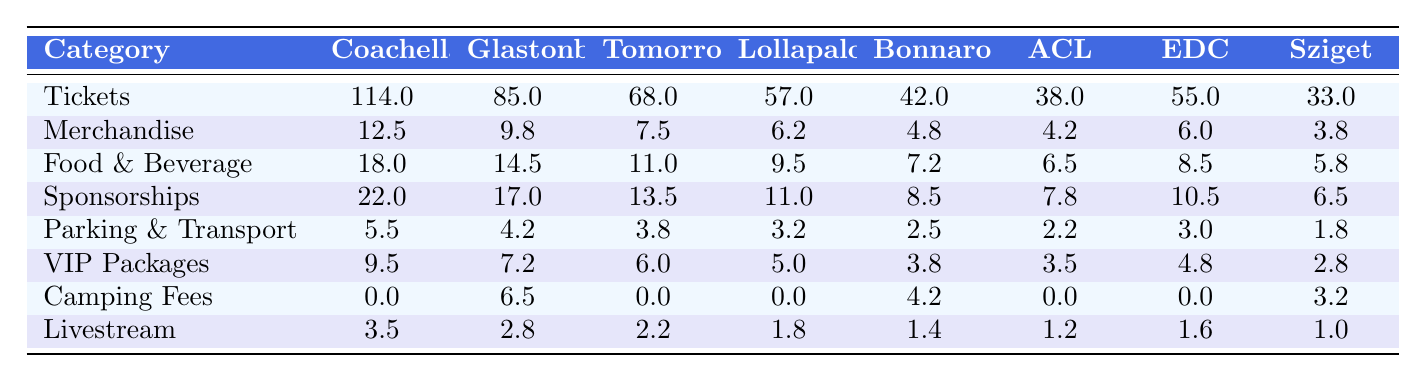What is the total revenue from ticket sales for Tomorrowland? According to the table, Tomorrowland has ticket sales of 68 million.
Answer: 68 million Which festival has the highest revenue from merchandise sales? The table shows that Coachella has the highest merchandise revenue of 12.5 million, compared to Glastonbury's 9.8 million and others.
Answer: Coachella What is the total revenue from food and beverage sales across all festivals? Adding the food and beverage sales together: 18 + 14.5 + 11 + 9.5 + 7.2 + 6.5 + 8.5 + 5.8 = 81 million.
Answer: 81 million Is the revenue from food and beverage sales for Lollapalooza greater than that for Bonnaroo? Lollapalooza has food and beverage sales of 9.5 million while Bonnaroo has 7.2 million; thus, Lollapalooza's revenue is higher.
Answer: Yes What is the difference in revenue from VIP packages between Coachella and Sziget Festival? Coachella has VIP packages revenue of 9.5 million and Sziget Festival has 2.8 million. The difference is 9.5 - 2.8 = 6.7 million.
Answer: 6.7 million What is the average revenue from parking and transportation across all festivals? Calculating the total for parking and transportation: 5.5 + 4.2 + 3.8 + 3.2 + 2.5 + 2.2 + 3.0 + 1.8 = 22.2 million. With 8 festivals, the average is 22.2 / 8 = 2.775 million.
Answer: 2.775 million Which festival has the lowest revenue from sponsorships? The sponsorship revenue for all festivals shows Sziget Festival has the lowest at 6.5 million.
Answer: Sziget Festival Calculate the total revenue from camping fees across all festivals. The camping fees displayed are: 0 + 6.5 + 0 + 0 + 4.2 + 0 + 0 + 3.2 = 13.9 million, indicating the total revenue.
Answer: 13.9 million If you combine the total revenues from ticket sales and sponsorships for Austin City Limits, what would that amount to? Austin City Limits has ticket sales of 38 million and sponsorships of 7.8 million. Summing them gives 38 + 7.8 = 45.8 million.
Answer: 45.8 million Is Glastonbury's revenue from livestream greater than that of Tomorrowland? Glastonbury has 2.8 million from livestream while Tomorrowland has 2.2 million, hence Glastonbury's revenue is greater.
Answer: Yes What percentage of the total revenue from food and beverage sales is contributed by the highest revenue festival in this category? The highest food and beverage revenue is from Glastonbury at 14.5 million. The total from food and beverage is 81 million. The percentage is (14.5 / 81) * 100 ≈ 17.91%.
Answer: 17.91% 